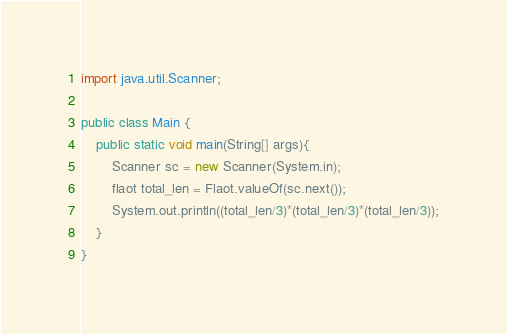<code> <loc_0><loc_0><loc_500><loc_500><_Java_>import java.util.Scanner;

public class Main {
    public static void main(String[] args){
        Scanner sc = new Scanner(System.in);
        flaot total_len = Flaot.valueOf(sc.next());
        System.out.println((total_len/3)*(total_len/3)*(total_len/3));
    }
}</code> 